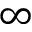<formula> <loc_0><loc_0><loc_500><loc_500>\infty</formula> 